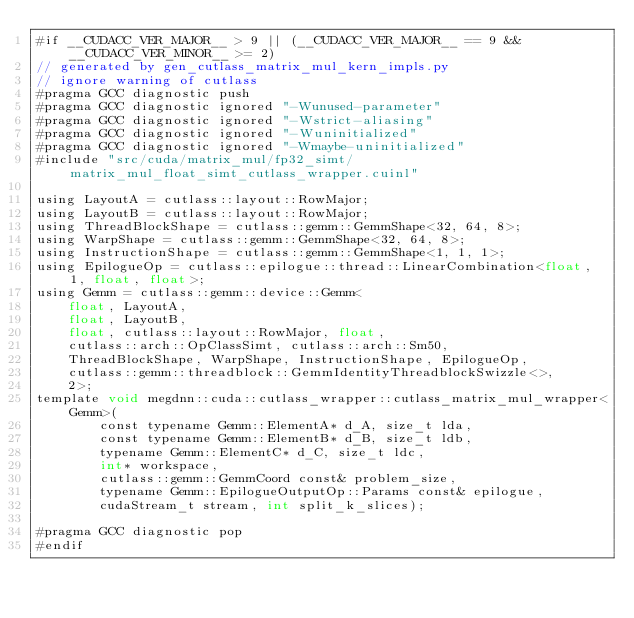Convert code to text. <code><loc_0><loc_0><loc_500><loc_500><_Cuda_>#if __CUDACC_VER_MAJOR__ > 9 || (__CUDACC_VER_MAJOR__ == 9 && __CUDACC_VER_MINOR__ >= 2)
// generated by gen_cutlass_matrix_mul_kern_impls.py
// ignore warning of cutlass
#pragma GCC diagnostic push
#pragma GCC diagnostic ignored "-Wunused-parameter"
#pragma GCC diagnostic ignored "-Wstrict-aliasing"
#pragma GCC diagnostic ignored "-Wuninitialized"
#pragma GCC diagnostic ignored "-Wmaybe-uninitialized"
#include "src/cuda/matrix_mul/fp32_simt/matrix_mul_float_simt_cutlass_wrapper.cuinl"

using LayoutA = cutlass::layout::RowMajor;
using LayoutB = cutlass::layout::RowMajor;
using ThreadBlockShape = cutlass::gemm::GemmShape<32, 64, 8>;
using WarpShape = cutlass::gemm::GemmShape<32, 64, 8>;
using InstructionShape = cutlass::gemm::GemmShape<1, 1, 1>;
using EpilogueOp = cutlass::epilogue::thread::LinearCombination<float, 1, float, float>;
using Gemm = cutlass::gemm::device::Gemm<
    float, LayoutA, 
    float, LayoutB, 
    float, cutlass::layout::RowMajor, float, 
    cutlass::arch::OpClassSimt, cutlass::arch::Sm50, 
    ThreadBlockShape, WarpShape, InstructionShape, EpilogueOp, 
    cutlass::gemm::threadblock::GemmIdentityThreadblockSwizzle<>, 
    2>;
template void megdnn::cuda::cutlass_wrapper::cutlass_matrix_mul_wrapper<Gemm>(
        const typename Gemm::ElementA* d_A, size_t lda, 
        const typename Gemm::ElementB* d_B, size_t ldb,  
        typename Gemm::ElementC* d_C, size_t ldc,  
        int* workspace, 
        cutlass::gemm::GemmCoord const& problem_size,   
        typename Gemm::EpilogueOutputOp::Params const& epilogue, 
        cudaStream_t stream, int split_k_slices);

#pragma GCC diagnostic pop
#endif
</code> 